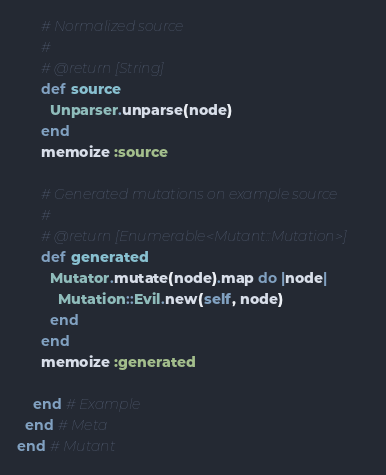<code> <loc_0><loc_0><loc_500><loc_500><_Ruby_>
      # Normalized source
      #
      # @return [String]
      def source
        Unparser.unparse(node)
      end
      memoize :source

      # Generated mutations on example source
      #
      # @return [Enumerable<Mutant::Mutation>]
      def generated
        Mutator.mutate(node).map do |node|
          Mutation::Evil.new(self, node)
        end
      end
      memoize :generated

    end # Example
  end # Meta
end # Mutant
</code> 